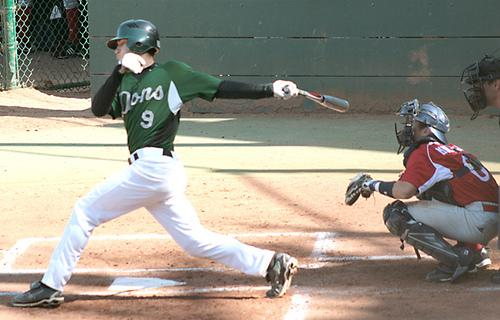Name the primary colors present on the catcher's outfit. Red, white, and black colors are noticeable on the catcher's outfit. Summarize the positions of the people in relation to the baseball game in the image. There is a batter swinging the bat, a catcher squatting behind the batter, and an umpire with a mask behind the catcher. Mention the key objects found in the image related to baseball. Bat, helmet, catchers mit, shin guard, baseball glove, home plate, wire mesh fence. Describe the number on the jersey and its color combination. The number 9 is visible on the green jersey with white lettering. What is special about the baseball players right shoe? The cleats on the baseball player's right shoe are emphasized. Identify the action performed by the baseball player in the image. The baseball player is swinging a bat attempting to hit the ball. Based on the information provided, state the main source of sentiment in the image. The main source of sentiment in the image is the intensity of the moment as a baseball player is attempting to hit the ball. What does the home base look like and where is it located in the image? Home base on the field appears as an off-white-colored shape and is positioned near the lower middle part of the image. According to the image, what objects are involved in the interaction between the baseball player and the catcher? The bat, the catchers mit, the baseball, and the home plate are involved in the interaction between the player and the catcher. Count the number of people mentioned in the image and their roles. There are three people mentioned: a baseball player or batter, a catcher, and an umpire. 